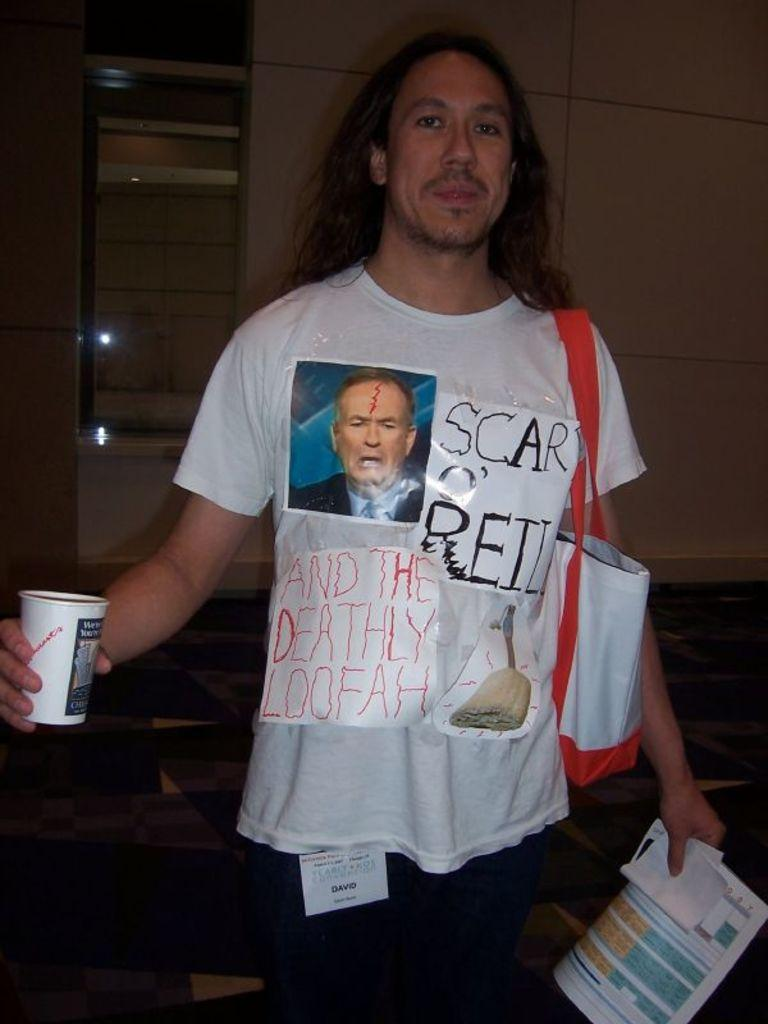Provide a one-sentence caption for the provided image. A man wears a shirt with the handwritten words "Scar O'Reilly and the Deathly Loofah" on it. 